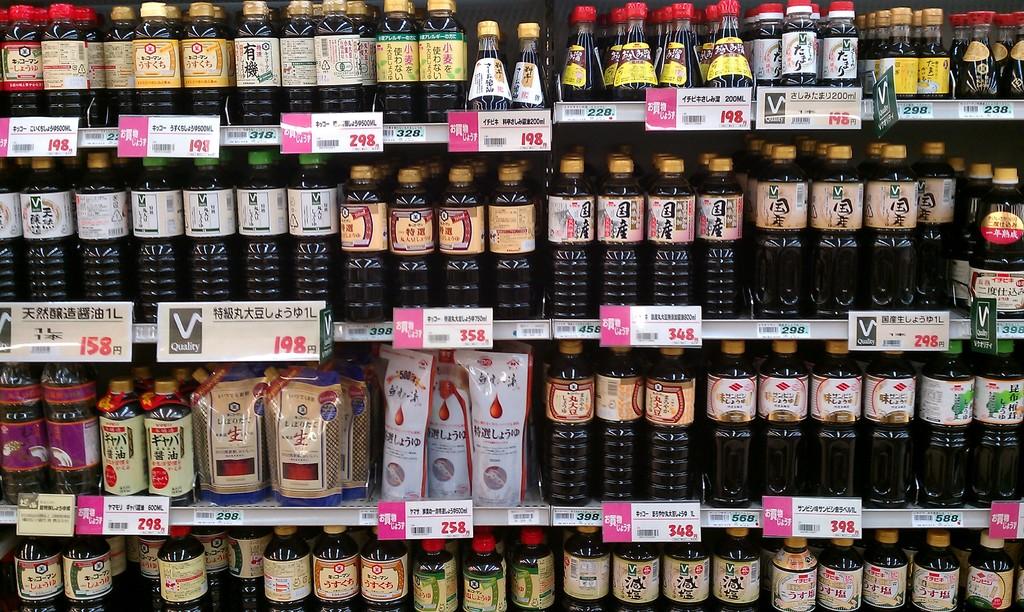What is the price of the product on the top right?
Ensure brevity in your answer.  238. What is the price of the products to the very bottom left?
Your response must be concise. 298. 